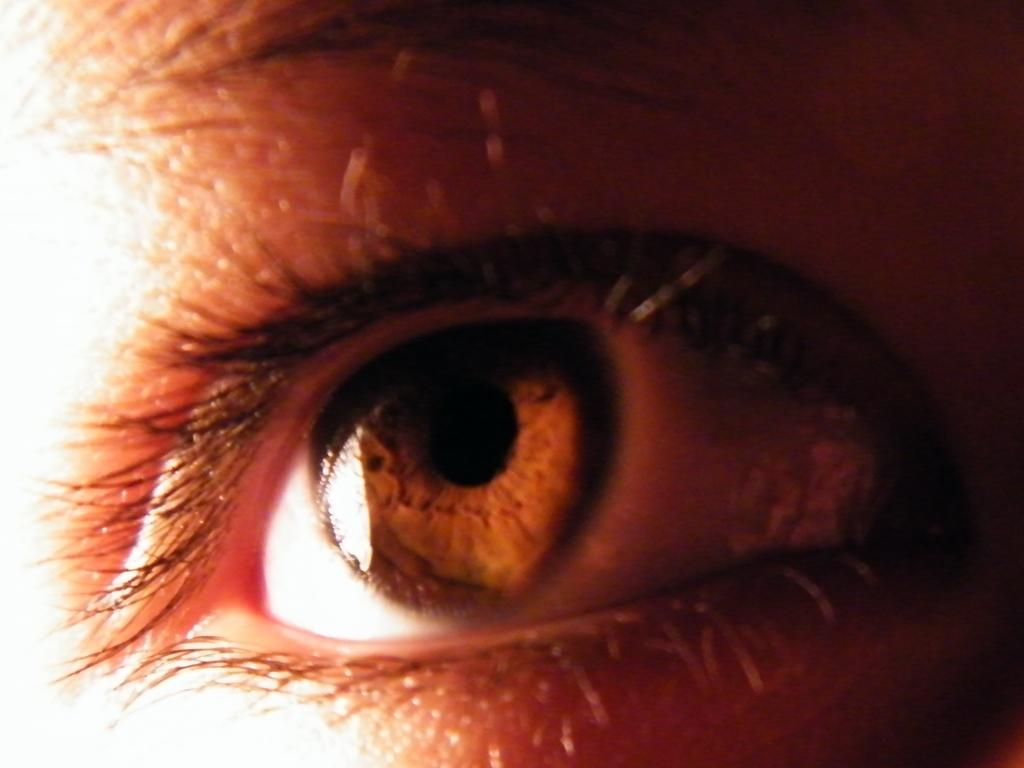What body part is the main focus of the image? There is a human eye in the image. What else can be seen in the image besides the eye? There is skin visible in the image, as well as eyebrows. What type of stocking is hanging on the frame in the image? There is no frame or stocking present in the image; it only features a human eye, skin, and eyebrows. 